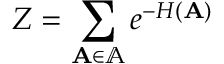<formula> <loc_0><loc_0><loc_500><loc_500>Z = \sum _ { A \in \mathbb { A } } e ^ { - H ( A ) }</formula> 